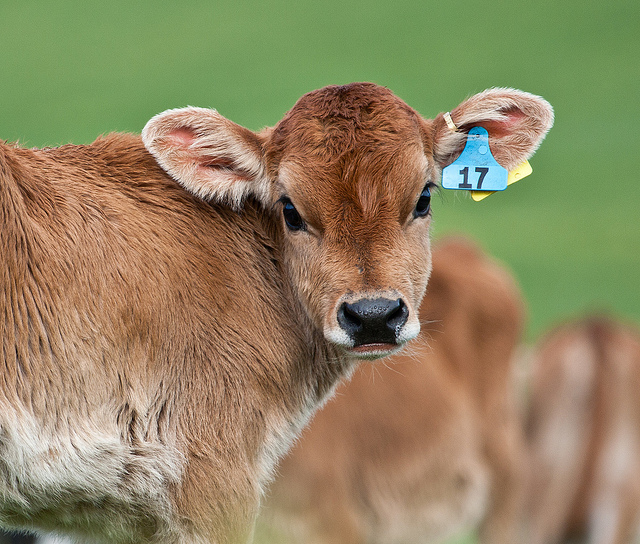Please transcribe the text in this image. 17 